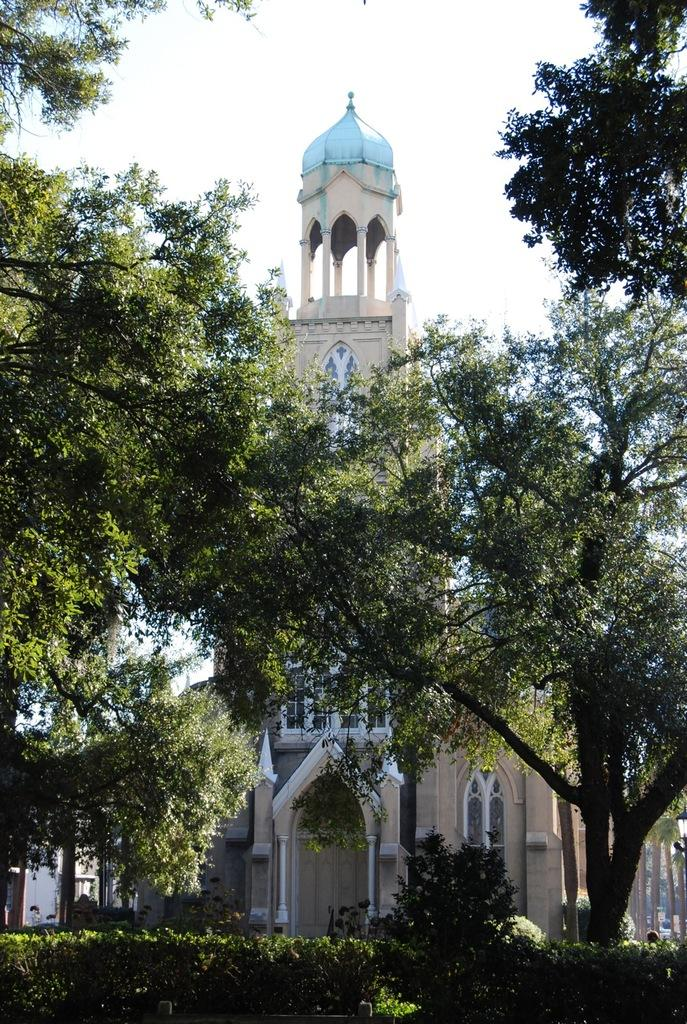What type of structures can be seen in the image? There are buildings in the image. What other natural elements are present in the image? There are plants and trees in the image. What is visible at the top of the image? The sky is visible at the top of the image. Can you tell me how many donkeys are grazing in the field in the image? There is no field or donkeys present in the image; it features buildings, plants, trees, and the sky. What type of meal is being prepared in the image? There is no meal preparation visible in the image. 